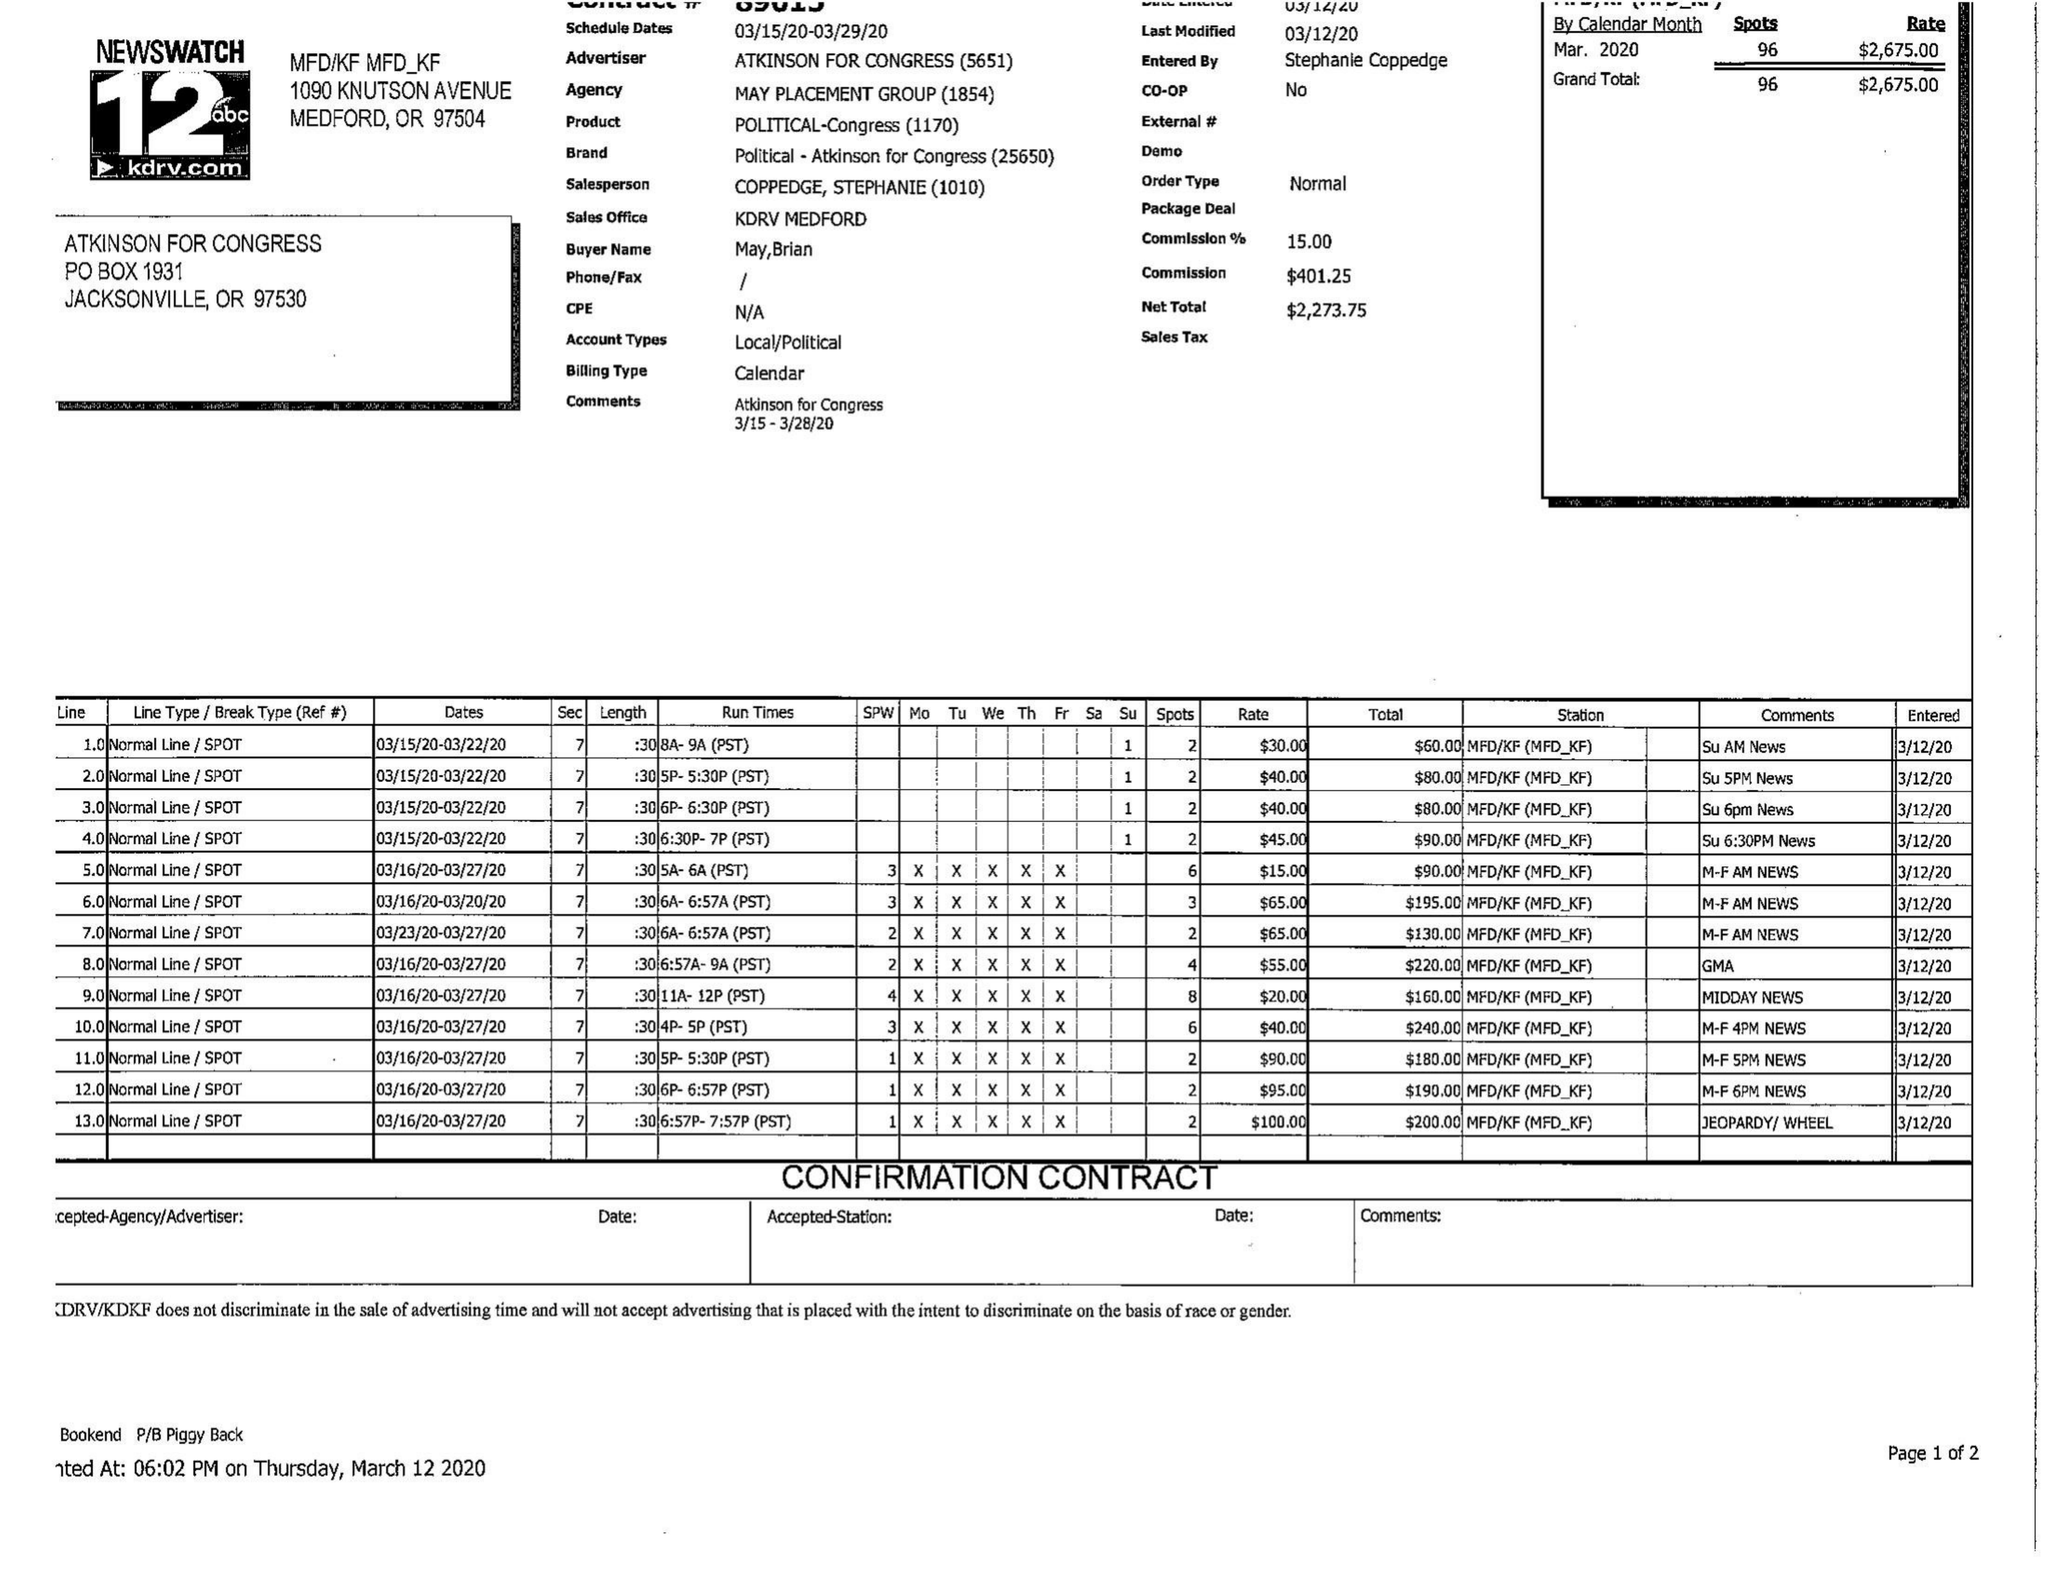What is the value for the flight_to?
Answer the question using a single word or phrase. 03/29/20 